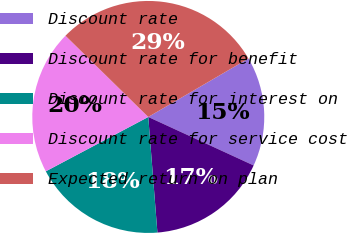<chart> <loc_0><loc_0><loc_500><loc_500><pie_chart><fcel>Discount rate<fcel>Discount rate for benefit<fcel>Discount rate for interest on<fcel>Discount rate for service cost<fcel>Expected return on plan<nl><fcel>15.27%<fcel>16.88%<fcel>18.49%<fcel>20.11%<fcel>29.25%<nl></chart> 